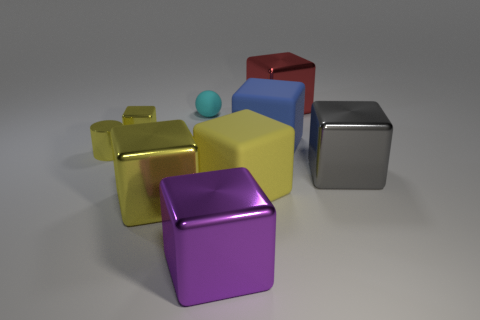Is the number of large purple things behind the small yellow metal block greater than the number of small yellow shiny cylinders on the right side of the large blue cube?
Offer a terse response. No. Is there any other thing that has the same color as the tiny ball?
Your answer should be very brief. No. There is a large block that is to the right of the large object behind the tiny cyan rubber object; are there any yellow things in front of it?
Make the answer very short. Yes. Do the big thing behind the large blue block and the tiny cyan matte thing have the same shape?
Give a very brief answer. No. Is the number of cyan balls left of the tiny rubber sphere less than the number of large yellow objects that are left of the gray thing?
Your response must be concise. Yes. What is the gray cube made of?
Offer a very short reply. Metal. Do the tiny matte ball and the large metal cube that is behind the tiny rubber thing have the same color?
Offer a very short reply. No. There is a yellow metal cylinder; what number of blue cubes are in front of it?
Keep it short and to the point. 0. Is the number of purple shiny things that are in front of the large gray cube less than the number of yellow matte cubes?
Give a very brief answer. No. What color is the metallic cylinder?
Provide a succinct answer. Yellow. 